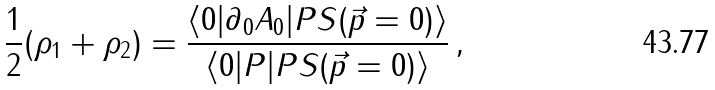<formula> <loc_0><loc_0><loc_500><loc_500>\frac { 1 } { 2 } ( \rho _ { 1 } + \rho _ { 2 } ) = \frac { \langle 0 | \partial _ { 0 } A _ { 0 } | P S ( \vec { p } = 0 ) \rangle } { \langle 0 | P | P S ( \vec { p } = 0 ) \rangle } \, ,</formula> 